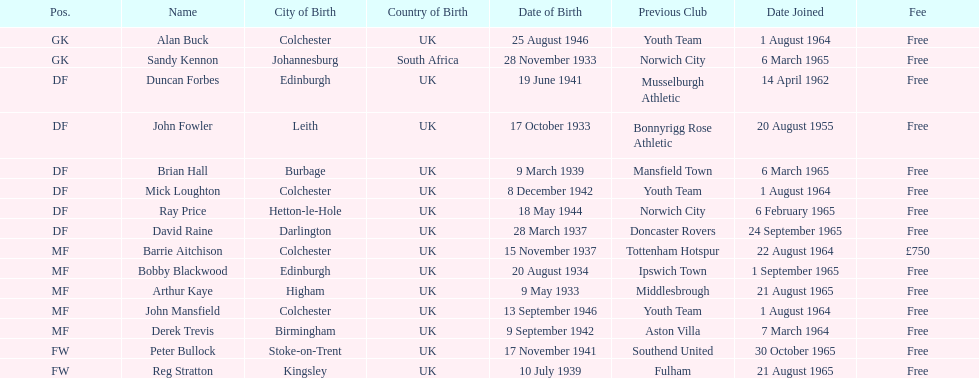How many players are listed as df? 6. 